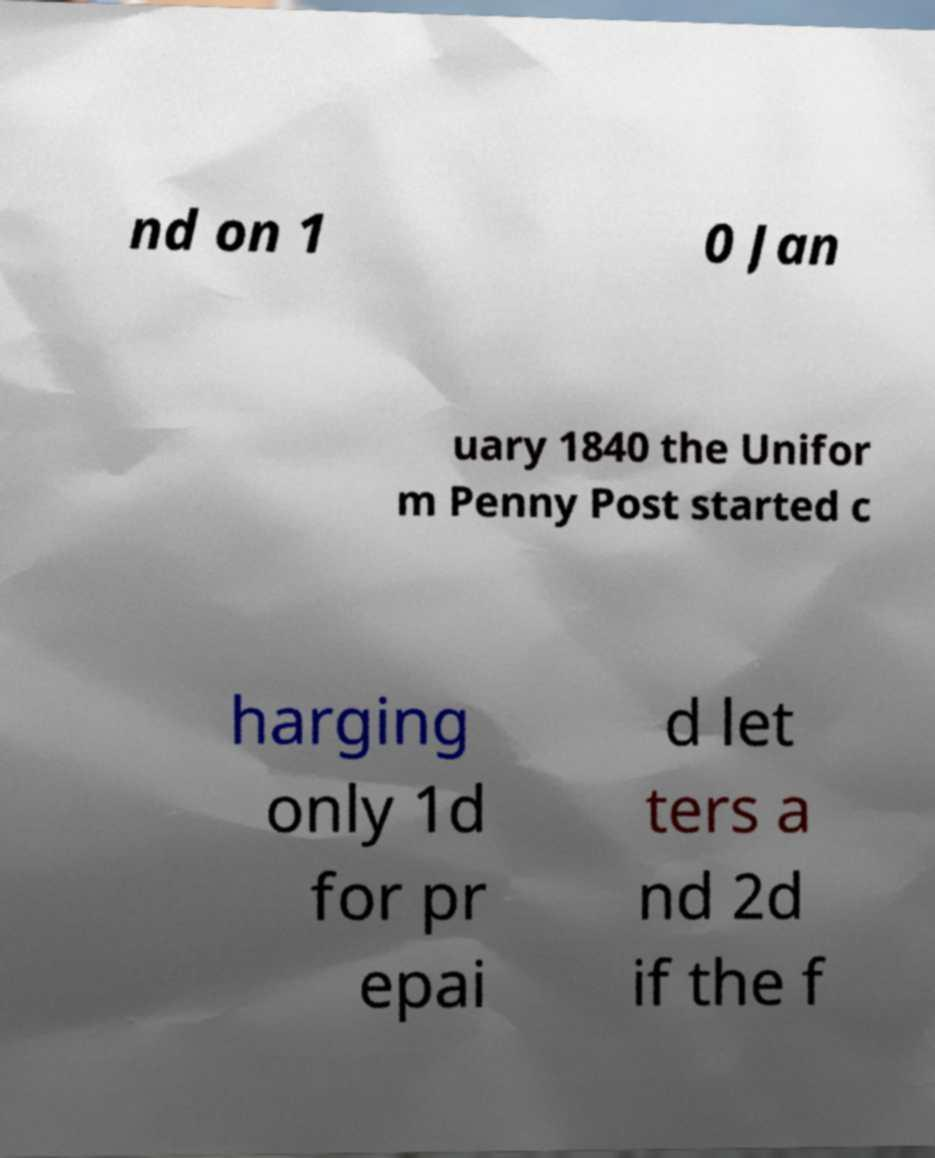Can you accurately transcribe the text from the provided image for me? nd on 1 0 Jan uary 1840 the Unifor m Penny Post started c harging only 1d for pr epai d let ters a nd 2d if the f 